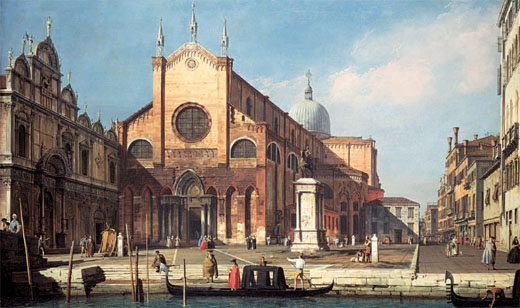What do you think is going on in this snapshot? This image beautifully captures a bustling scene in a Venetian cityscape. The central focus is a grand Gothic church, notable for its impressive dome and towering spires. The intricate architectural details of the church are meticulously portrayed, showcasing an exceptional level of skill and accuracy. It's a sunny day, with a vibrant blue sky scattered with a few clouds, adding to the charm. The painting is alive with activity; people are seen engaging in their daily routines - walking, talking, and even boarding gondolas at the water's edge. The warm color palette, dominated by reds and soft hues, imbues the scene with a welcoming, lively atmosphere. This artwork not only highlights the architectural grandeur of Venice but also provides a glimpse into the everyday lives of its inhabitants, making it a perfect blend of landscape and genre painting. 